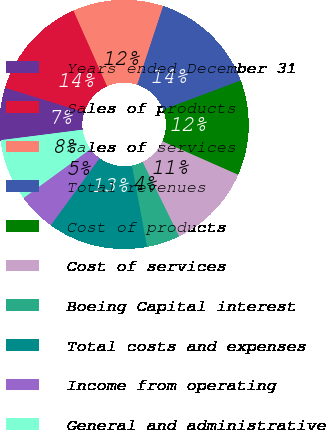<chart> <loc_0><loc_0><loc_500><loc_500><pie_chart><fcel>Years ended December 31<fcel>Sales of products<fcel>Sales of services<fcel>Total revenues<fcel>Cost of products<fcel>Cost of services<fcel>Boeing Capital interest<fcel>Total costs and expenses<fcel>Income from operating<fcel>General and administrative<nl><fcel>6.79%<fcel>13.58%<fcel>11.73%<fcel>14.2%<fcel>12.35%<fcel>11.11%<fcel>4.32%<fcel>12.96%<fcel>4.94%<fcel>8.02%<nl></chart> 